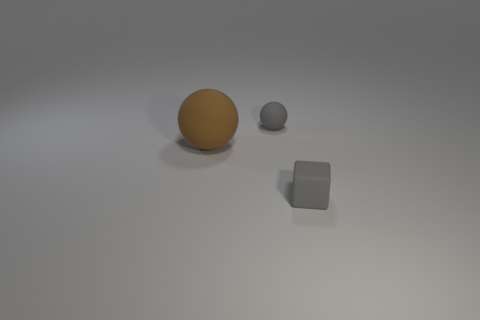What might be the possible materials of these objects? Based on the image, the larger sphere may be made of polished wood or plastic due to its shininess, the gray sphere might be ceramic or stone, and the cube could be made of concrete or plaster. 